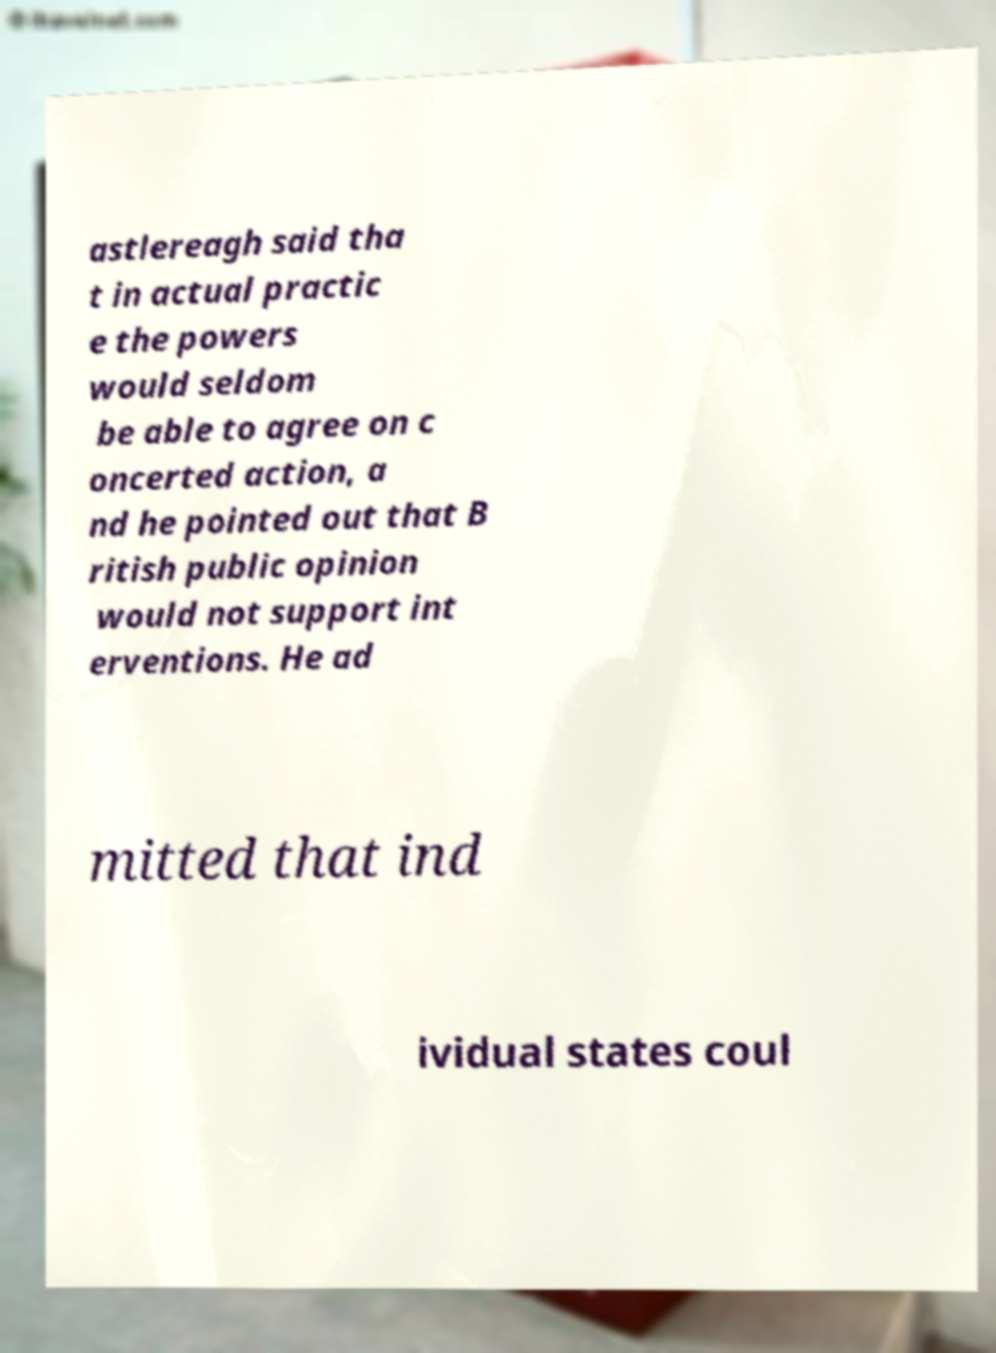Could you assist in decoding the text presented in this image and type it out clearly? astlereagh said tha t in actual practic e the powers would seldom be able to agree on c oncerted action, a nd he pointed out that B ritish public opinion would not support int erventions. He ad mitted that ind ividual states coul 